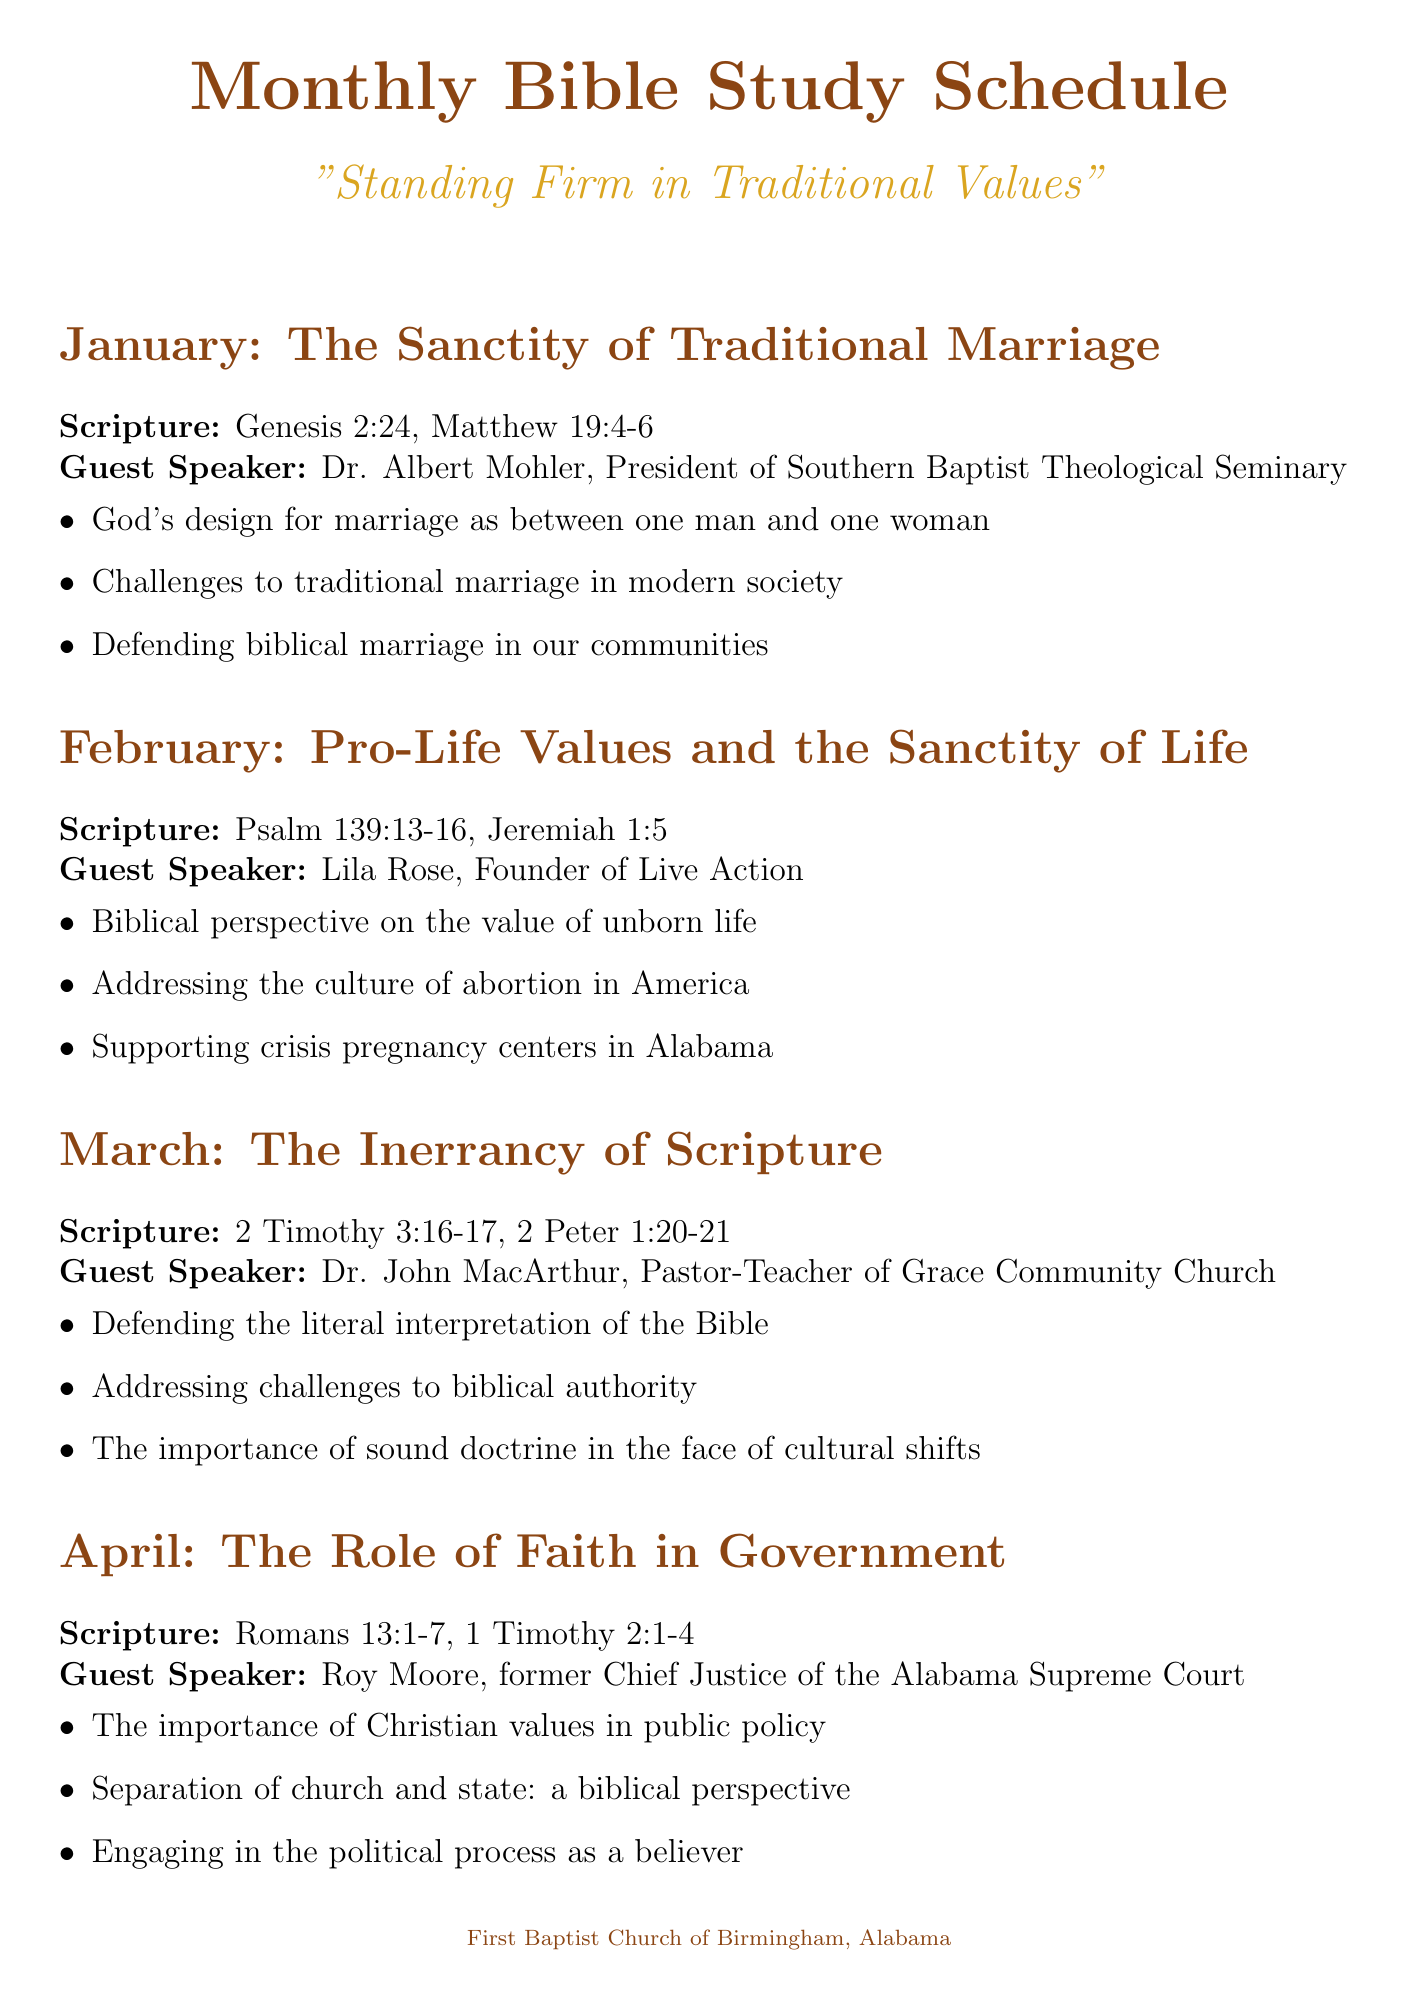What is the topic for January? The topic for January is stated in the schedule, which is "The Sanctity of Traditional Marriage."
Answer: The Sanctity of Traditional Marriage Who is the guest speaker for February? The guest speaker is listed for each month, and for February, it is Lila Rose.
Answer: Lila Rose What scripture is referenced for March's meeting? The scripture is provided in the schedule under each month's topic, for March it is 2 Timothy 3:16-17, 2 Peter 1:20-21.
Answer: 2 Timothy 3:16-17, 2 Peter 1:20-21 How many discussion points are listed for June? The number of discussion points can be counted from the June entry in the document, which lists three points under the topic.
Answer: 3 What is the topic for the meeting in April? The topic for the April meeting is explicitly mentioned in the document schedule.
Answer: The Role of Faith in Government Who is the guest speaker for May? The guest speaker for May is stated in the schedule, which is Dr. James Dobson.
Answer: Dr. James Dobson What is the focus of the June discussion points? The discussion points for June focus on a specific theme, which is provided in the document.
Answer: Creation vs. Evolution What does the scripture for January include? The specific scriptures referenced in the January section are included in the document.
Answer: Genesis 2:24, Matthew 19:4-6 